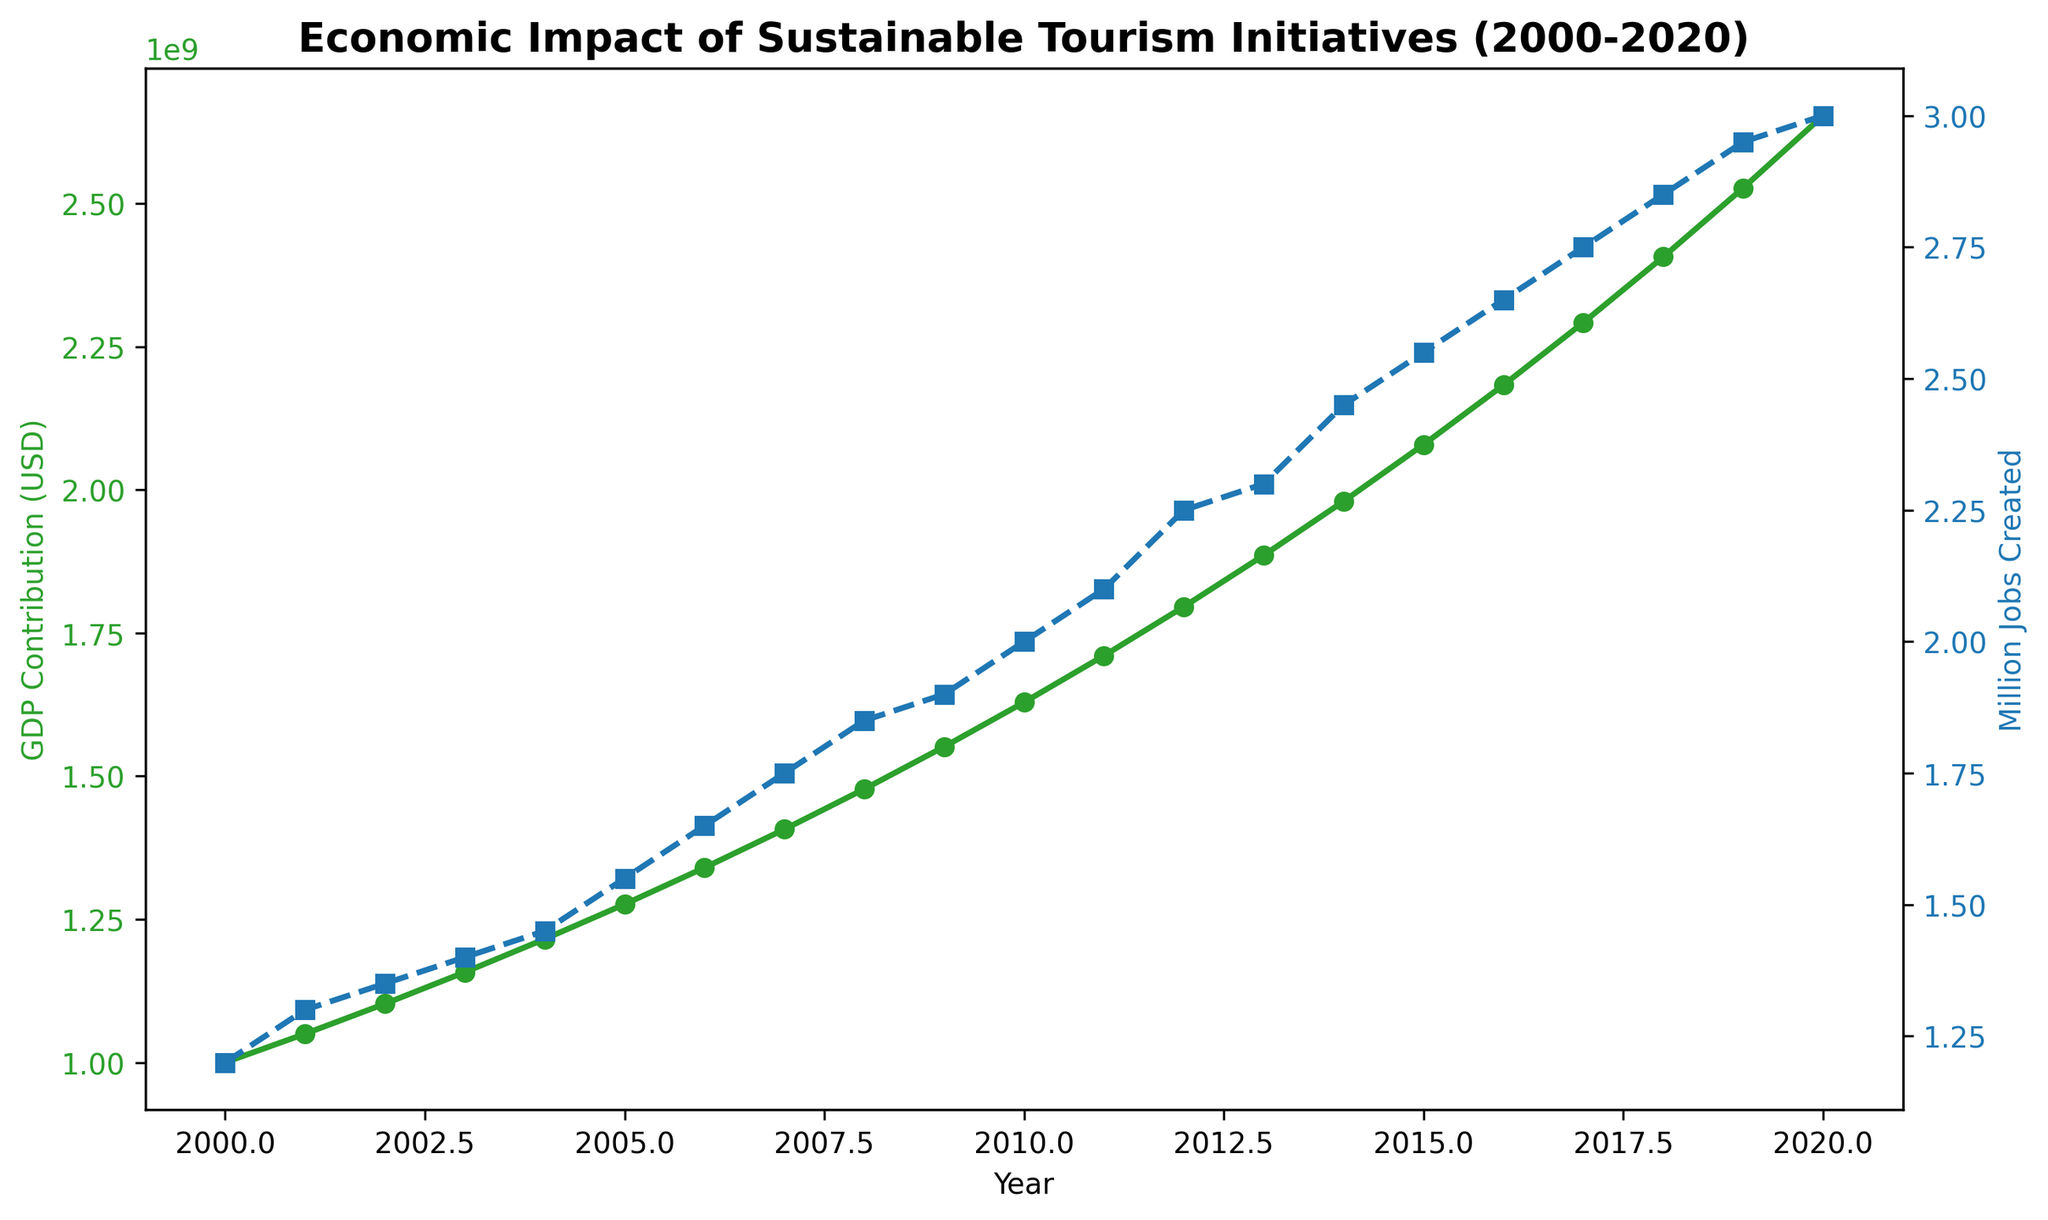Which year had the highest GDP contribution from sustainable tourism? From the green line on the chart, we can see that the GDP contribution consistently increased from 2000 to 2020. The highest point is in 2020.
Answer: 2020 How many million jobs were created due to sustainable tourism in 2015? We look at the blue line representing million jobs created and focus on the year 2015. The value at this point is 2.55 million jobs.
Answer: 2.55 million jobs What is the total GDP contribution of sustainable tourism from 2000 to 2010? We sum the GDP contributions from 2000 ($1,000,000,000) to 2010 ($1,628,894,626). Adding these values: \$1,000,000,000 + \$1,050,000,000 + \$1,102,500,000 + \$1,157,625,000 + \$1,215,506,250 + \$1,276,281,562 + \$1,340,095,640 + \$1,407,100,422 + \$1,477,455,443 + \$1,551,328,215 + \$1,628,894,626 = \$15,207,787,158.
Answer: $15,207,787,158 How did the number of jobs created change from 2005 to 2015? In 2005, 1.55 million jobs were created, and in 2015, 2.55 million jobs were created. The change in the number of jobs is calculated by subtracting the 2005 value from the 2015 value: 2.55 - 1.55 = 1.00 million jobs.
Answer: Increased by 1.00 million jobs In which period did the GDP contribution experience the slowest growth and by how much? By examining the green line's steepness, we see the slowest growth between 2008 and 2009. The GDP contribution in 2008 was $1,477,455,443, and in 2009 it was $1,551,328,215. The growth is calculated as $1,551,328,215 - $1,477,455,443 = $73,872,772.
Answer: 2008-2009, $73,872,772 Compare the percentage increase in GDP contribution between 2000-2005 and 2015-2020. First, calculate the GDP contribution increase for each period and then find the percentage increase.
2000-2005: From $1,000,000,000 to $1,276,281,562. Increase: $1,276,281,562 - $1,000,000,000 = $276,281,562. Percentage increase: ($276,281,562 / $1,000,000,000) * 100 = 27.63%.
2015-2020: From $2,078,928,177 to $2,653,297,703. Increase: $2,653,297,703 - $2,078,928,177 = $574,369,526. Percentage increase: ($574,369,526 / $2,078,928,177) * 100 = 27.63%.
Both periods have the same percentage increase.
Answer: 27.63% for both periods 